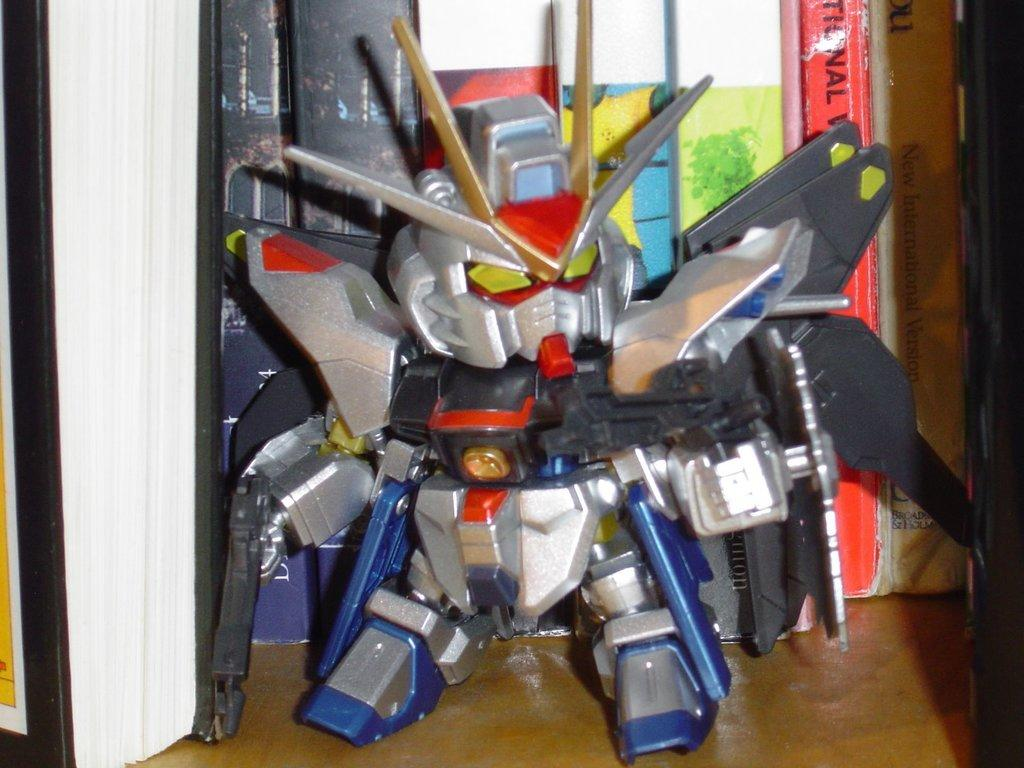What objects are located in the center of the image? There are tools in the center of the image. What type of death is depicted in the image? There is no depiction of death in the image; it features tools in the center. What type of basin is visible in the image? There is no basin present in the image; it features tools in the center. 